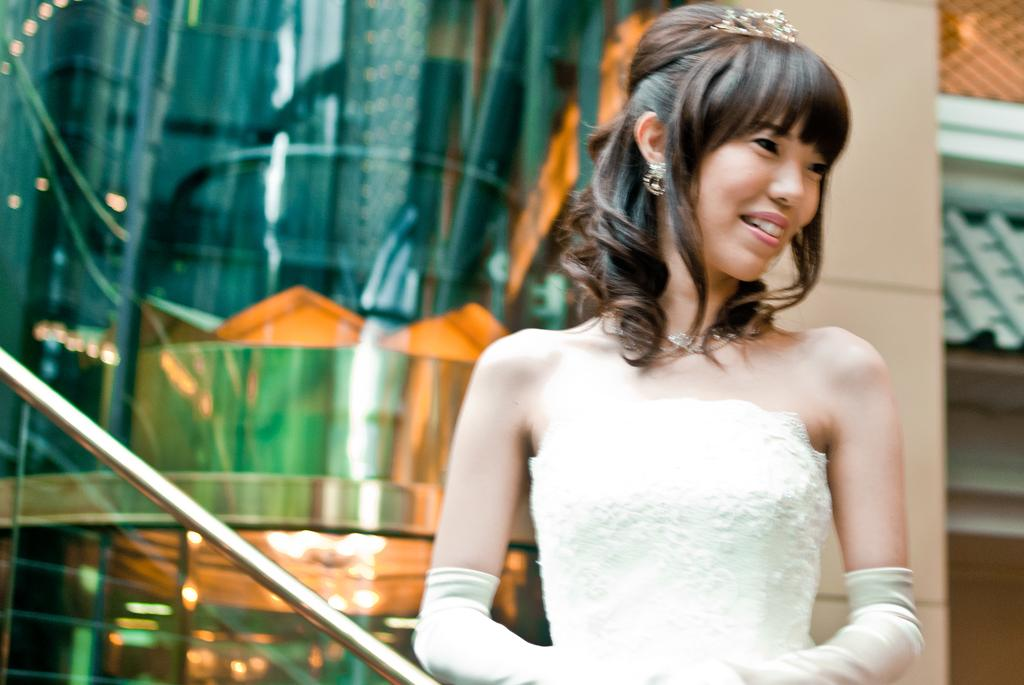Who is the main subject in the picture? There is a girl in the picture. What is the girl wearing? The girl is wearing a white dress. What is the girl doing in the picture? The girl is standing and smiling. What can be seen in the background of the picture? There is a building in the background of the picture. What type of suit can be seen on the snails in the image? There are no snails or suits present in the image. How does the girl use the brake in the image? There is no brake present in the image, and the girl is not shown using any such device. 